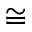Convert formula to latex. <formula><loc_0><loc_0><loc_500><loc_500>\cong</formula> 